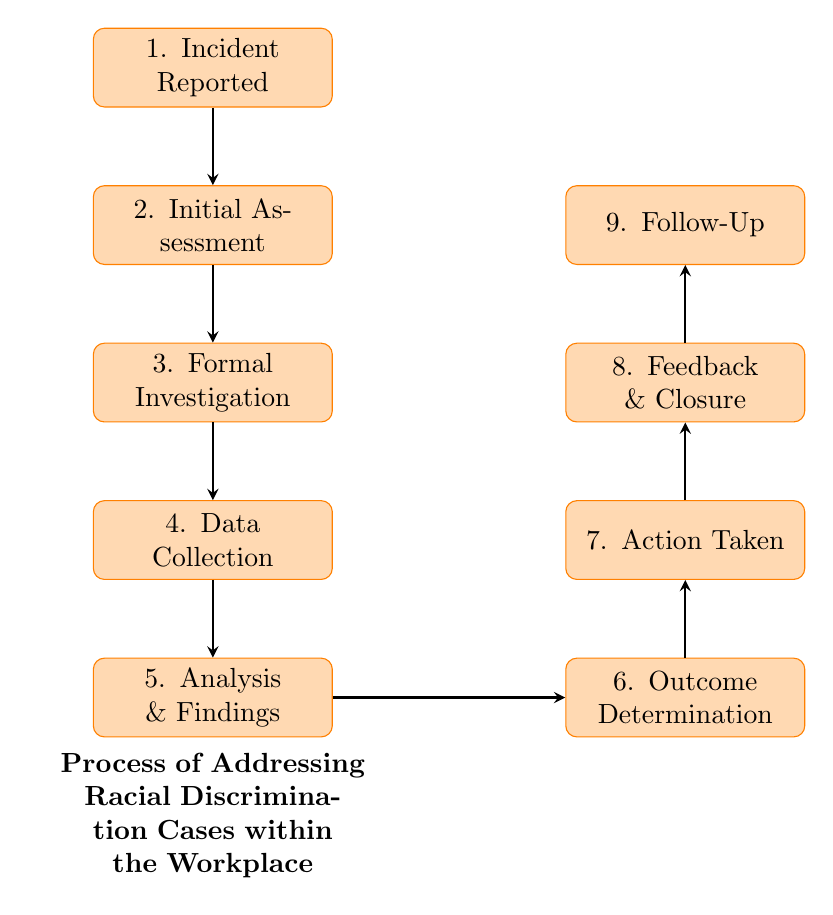What is the first step in addressing racial discrimination cases? The diagram shows that the first node is "Incident Reported," indicating that this is the initial step in the process.
Answer: Incident Reported How many nodes are present in the diagram? By counting each labeled process in the diagram, we find there are a total of nine distinct nodes.
Answer: Nine What is the action taken after "Outcome Determination"? The flow chart indicates that the action following "Outcome Determination" is "Action Taken," which directly addresses the previous step.
Answer: Action Taken Which step includes gathering relevant documents and emails? The node labeled "Data Collection" explicitly states the gathering of relevant documents and emails as part of the process.
Answer: Data Collection What follows "Feedback & Closure" in the process? According to the flow of the diagram, after "Feedback & Closure," the next step is "Follow-Up," which is a subsequent action to ensure case resolution.
Answer: Follow-Up What is the relationship between "Initial Assessment" and "Formal Investigation"? The flow chart demonstrates a sequential connection where "Initial Assessment" leads directly into "Formal Investigation," indicating a progression of events in the process.
Answer: Initial Assessment → Formal Investigation Which step involves analyzing collected data? The node explicitly labeled "Analysis & Findings" identifies that this is where the collected data is analyzed within the process.
Answer: Analysis & Findings What type of actions can occur after "Outcome Determination"? The flow chart shows that the potential results of the "Outcome Determination" can include disciplinary actions or policy changes, as noted within the description of that node.
Answer: Disciplinary actions or policy changes How does the process ensure workplace culture improves after a case? The last step, "Follow-Up," indicates that periodic checks aim to ensure there is no retaliation and that the workplace culture improves, which makes this a critical step.
Answer: Follow-Up 